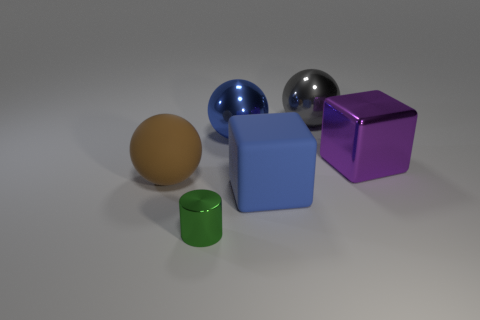How many other things are the same shape as the gray thing?
Offer a terse response. 2. What shape is the tiny shiny object?
Offer a terse response. Cylinder. Does the purple thing have the same material as the tiny object?
Your response must be concise. Yes. Is the number of metallic things that are left of the matte ball the same as the number of big brown things that are in front of the green cylinder?
Make the answer very short. Yes. There is a big shiny ball that is on the left side of the ball that is behind the large blue metallic thing; are there any tiny shiny things that are behind it?
Provide a short and direct response. No. Does the green metal thing have the same size as the brown thing?
Offer a terse response. No. What color is the large cube that is in front of the object on the right side of the large ball that is right of the blue metal thing?
Offer a terse response. Blue. What number of large shiny spheres have the same color as the matte cube?
Your answer should be compact. 1. How many big things are green blocks or metallic cylinders?
Your answer should be compact. 0. Are there any shiny objects that have the same shape as the big blue rubber object?
Give a very brief answer. Yes. 